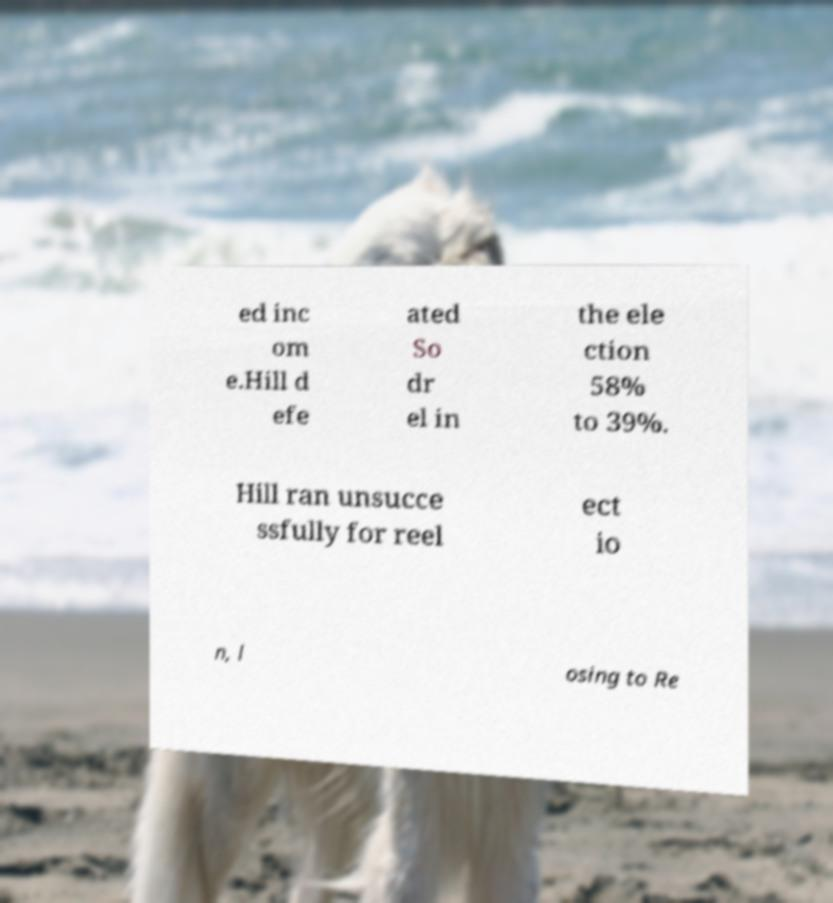Could you extract and type out the text from this image? ed inc om e.Hill d efe ated So dr el in the ele ction 58% to 39%. Hill ran unsucce ssfully for reel ect io n, l osing to Re 